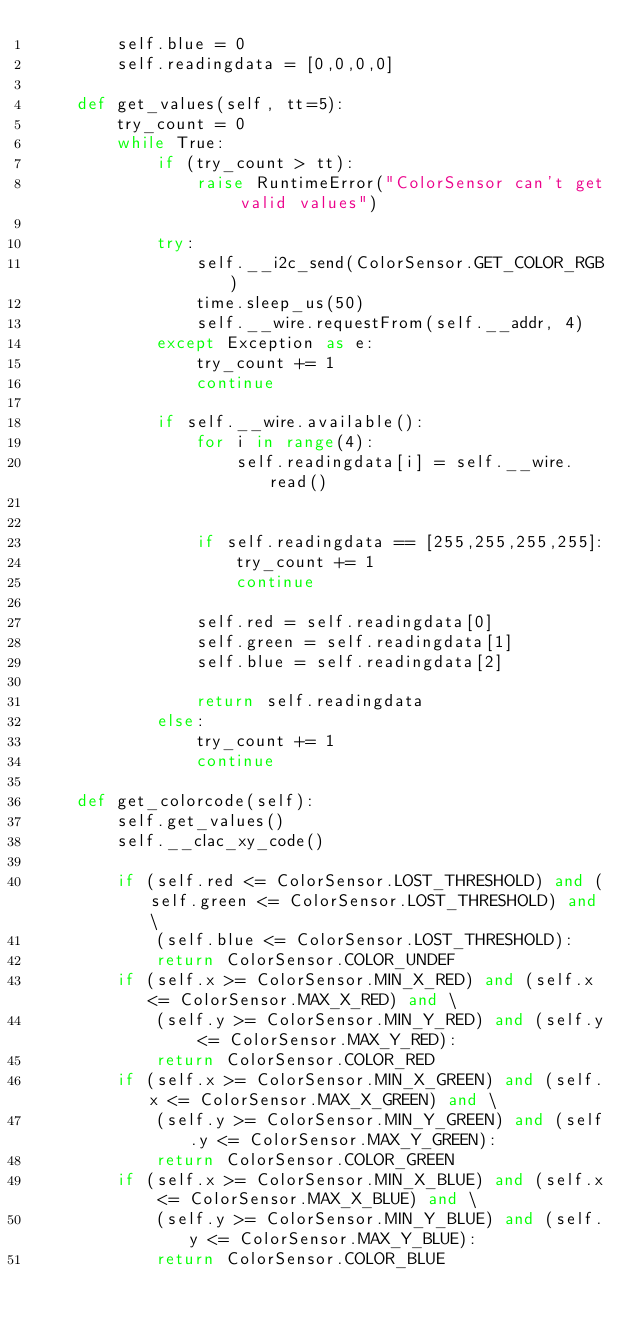<code> <loc_0><loc_0><loc_500><loc_500><_Python_>        self.blue = 0
        self.readingdata = [0,0,0,0]

    def get_values(self, tt=5):
        try_count = 0
        while True:
            if (try_count > tt):
                raise RuntimeError("ColorSensor can't get valid values")
          
            try:
                self.__i2c_send(ColorSensor.GET_COLOR_RGB)
                time.sleep_us(50)
                self.__wire.requestFrom(self.__addr, 4)
            except Exception as e:
                try_count += 1
                continue

            if self.__wire.available():
                for i in range(4):
                    self.readingdata[i] = self.__wire.read()

                
                if self.readingdata == [255,255,255,255]:
                    try_count += 1
                    continue

                self.red = self.readingdata[0]
                self.green = self.readingdata[1]
                self.blue = self.readingdata[2]
            
                return self.readingdata
            else:
                try_count += 1
                continue

    def get_colorcode(self):
        self.get_values()
        self.__clac_xy_code()

        if (self.red <= ColorSensor.LOST_THRESHOLD) and (self.green <= ColorSensor.LOST_THRESHOLD) and \
            (self.blue <= ColorSensor.LOST_THRESHOLD):
            return ColorSensor.COLOR_UNDEF
        if (self.x >= ColorSensor.MIN_X_RED) and (self.x <= ColorSensor.MAX_X_RED) and \
            (self.y >= ColorSensor.MIN_Y_RED) and (self.y <= ColorSensor.MAX_Y_RED):
            return ColorSensor.COLOR_RED
        if (self.x >= ColorSensor.MIN_X_GREEN) and (self.x <= ColorSensor.MAX_X_GREEN) and \
            (self.y >= ColorSensor.MIN_Y_GREEN) and (self.y <= ColorSensor.MAX_Y_GREEN):
            return ColorSensor.COLOR_GREEN
        if (self.x >= ColorSensor.MIN_X_BLUE) and (self.x <= ColorSensor.MAX_X_BLUE) and \
            (self.y >= ColorSensor.MIN_Y_BLUE) and (self.y <= ColorSensor.MAX_Y_BLUE):
            return ColorSensor.COLOR_BLUE</code> 